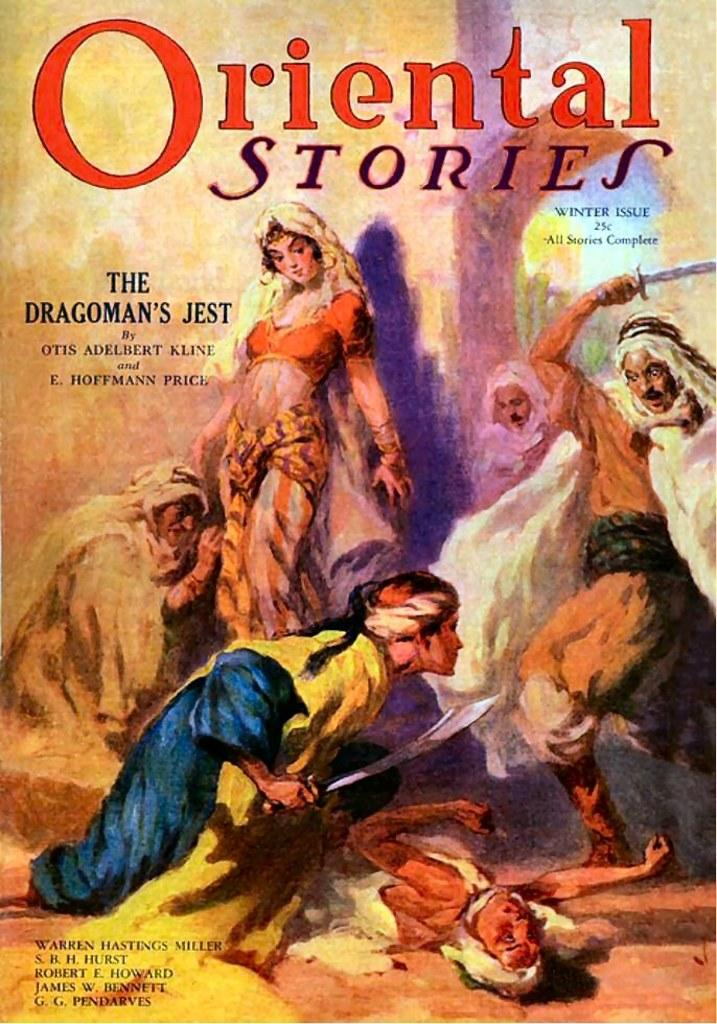What is the main subject of the image? The main subject of the image is a book cover. What else can be seen in the center of the image? There are people in the center of the image. Where is text located in the image? There is text at the top and bottom of the image. How many clocks are visible on the book cover in the image? There are no clocks visible on the book cover in the image. What type of legal advice is the lawyer providing in the image? There is no lawyer present in the image, so no legal advice can be provided. 